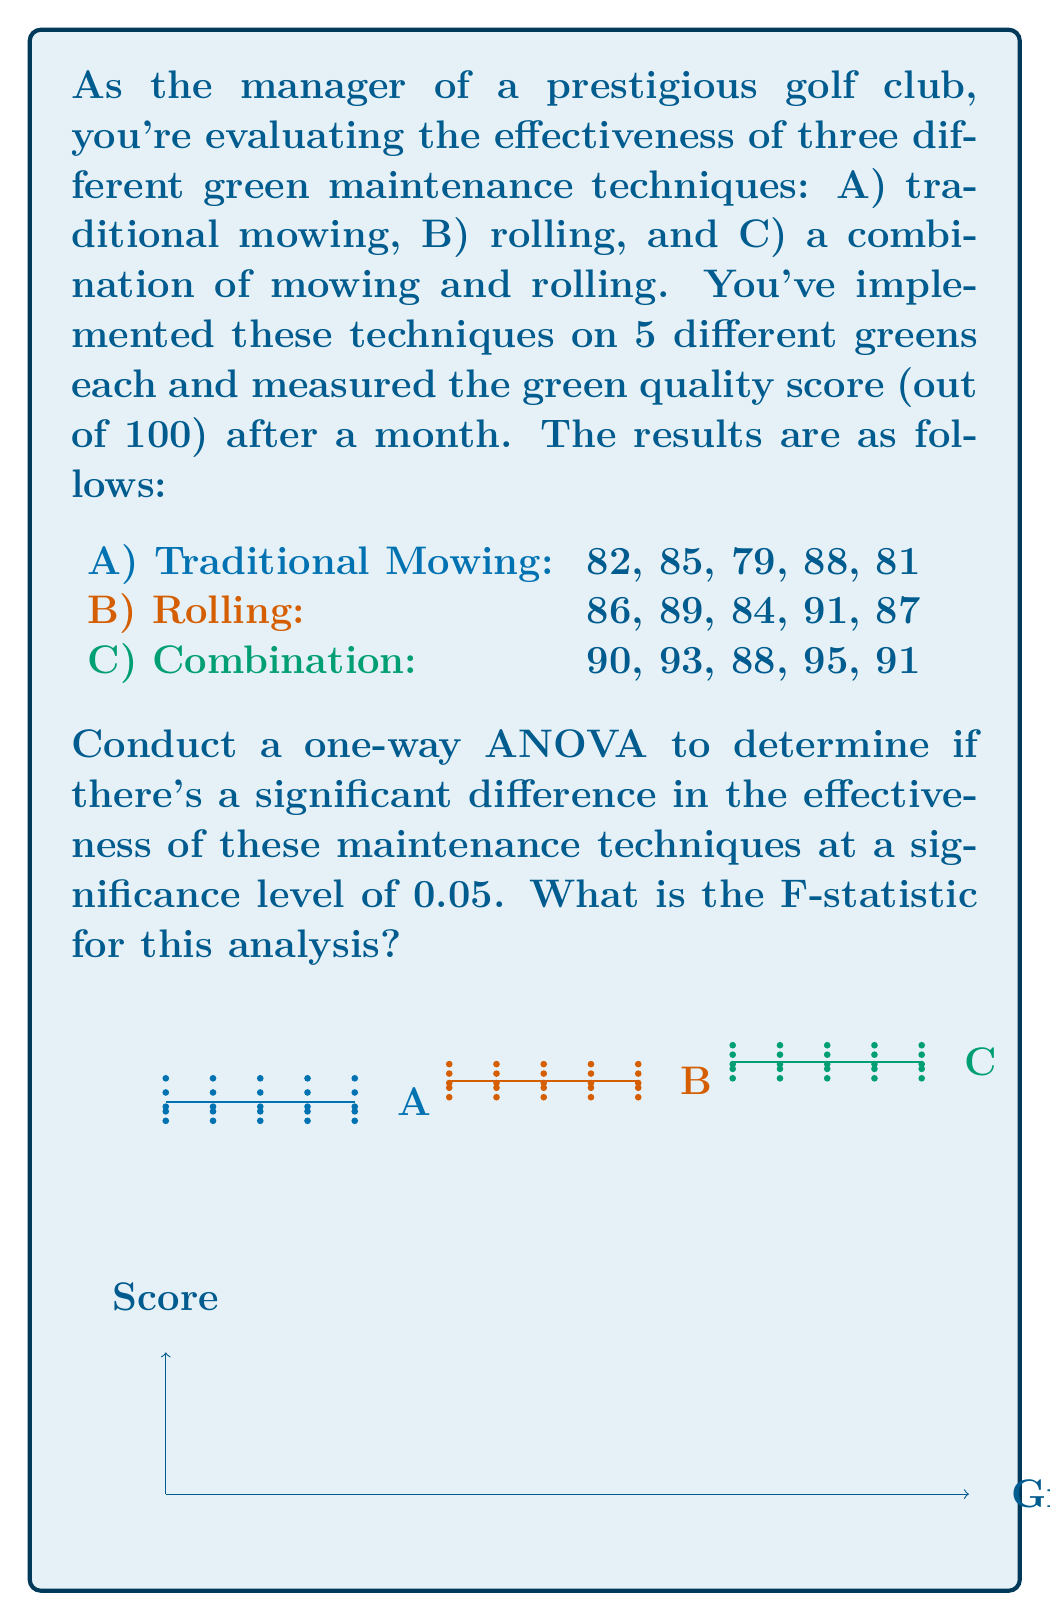Can you answer this question? To conduct a one-way ANOVA, we'll follow these steps:

1) Calculate the mean for each group:
   $\bar{X}_A = \frac{82 + 85 + 79 + 88 + 81}{5} = 83$
   $\bar{X}_B = \frac{86 + 89 + 84 + 91 + 87}{5} = 87.4$
   $\bar{X}_C = \frac{90 + 93 + 88 + 95 + 91}{5} = 91.4$

2) Calculate the grand mean:
   $\bar{X} = \frac{83 + 87.4 + 91.4}{3} = 87.27$

3) Calculate the Sum of Squares Between (SSB):
   $$SSB = 5[(83 - 87.27)^2 + (87.4 - 87.27)^2 + (91.4 - 87.27)^2] = 176.13$$

4) Calculate the Sum of Squares Within (SSW):
   $$SSW = \sum_{i=1}^{3}\sum_{j=1}^{5}(X_{ij} - \bar{X}_i)^2 = 138$$

5) Calculate the degrees of freedom:
   $df_{between} = k - 1 = 3 - 1 = 2$ (where k is the number of groups)
   $df_{within} = N - k = 15 - 3 = 12$ (where N is the total number of observations)

6) Calculate the Mean Square Between (MSB) and Mean Square Within (MSW):
   $$MSB = \frac{SSB}{df_{between}} = \frac{176.13}{2} = 88.065$$
   $$MSW = \frac{SSW}{df_{within}} = \frac{138}{12} = 11.5$$

7) Calculate the F-statistic:
   $$F = \frac{MSB}{MSW} = \frac{88.065}{11.5} = 7.66$$

Therefore, the F-statistic for this analysis is 7.66.
Answer: 7.66 